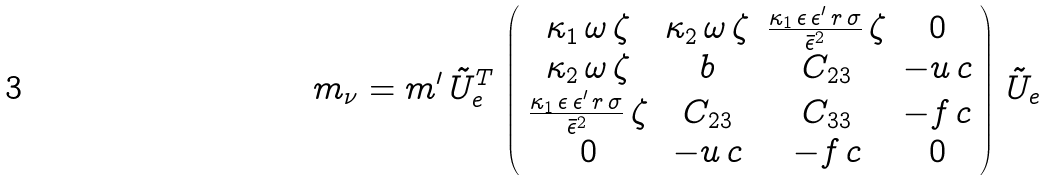Convert formula to latex. <formula><loc_0><loc_0><loc_500><loc_500>m _ { \nu } = m ^ { \prime } \, \tilde { U } _ { e } ^ { T } \, \left ( \begin{array} { c c c c } \kappa _ { 1 } \, \omega \, \zeta & \kappa _ { 2 } \, \omega \, \zeta & \frac { \kappa _ { 1 } \, \epsilon \, \epsilon ^ { \prime } \, r \, \sigma } { \bar { \epsilon } ^ { 2 } } \, \zeta & 0 \\ \kappa _ { 2 } \, \omega \, \zeta & b & C _ { 2 3 } & - u \, c \\ \frac { \kappa _ { 1 } \, \epsilon \, \epsilon ^ { \prime } \, r \, \sigma } { \bar { \epsilon } ^ { 2 } } \, \zeta & C _ { 2 3 } & C _ { 3 3 } & - f \, c \\ 0 & - u \, c & - f \, c & 0 \end{array} \right ) \, \tilde { U } _ { e }</formula> 